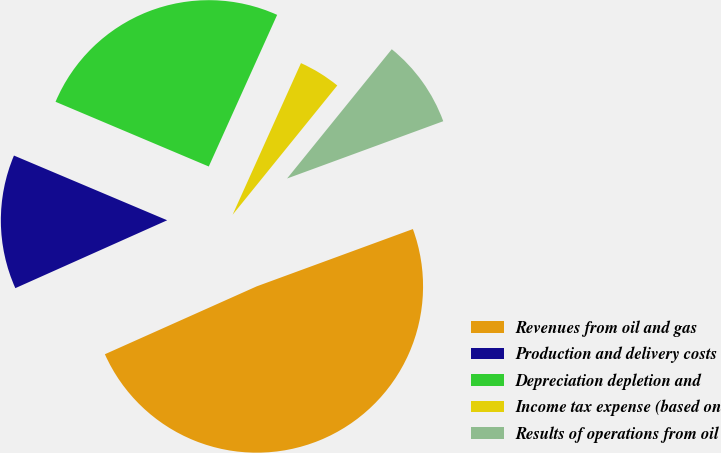Convert chart to OTSL. <chart><loc_0><loc_0><loc_500><loc_500><pie_chart><fcel>Revenues from oil and gas<fcel>Production and delivery costs<fcel>Depreciation depletion and<fcel>Income tax expense (based on<fcel>Results of operations from oil<nl><fcel>48.9%<fcel>13.05%<fcel>25.38%<fcel>4.09%<fcel>8.57%<nl></chart> 